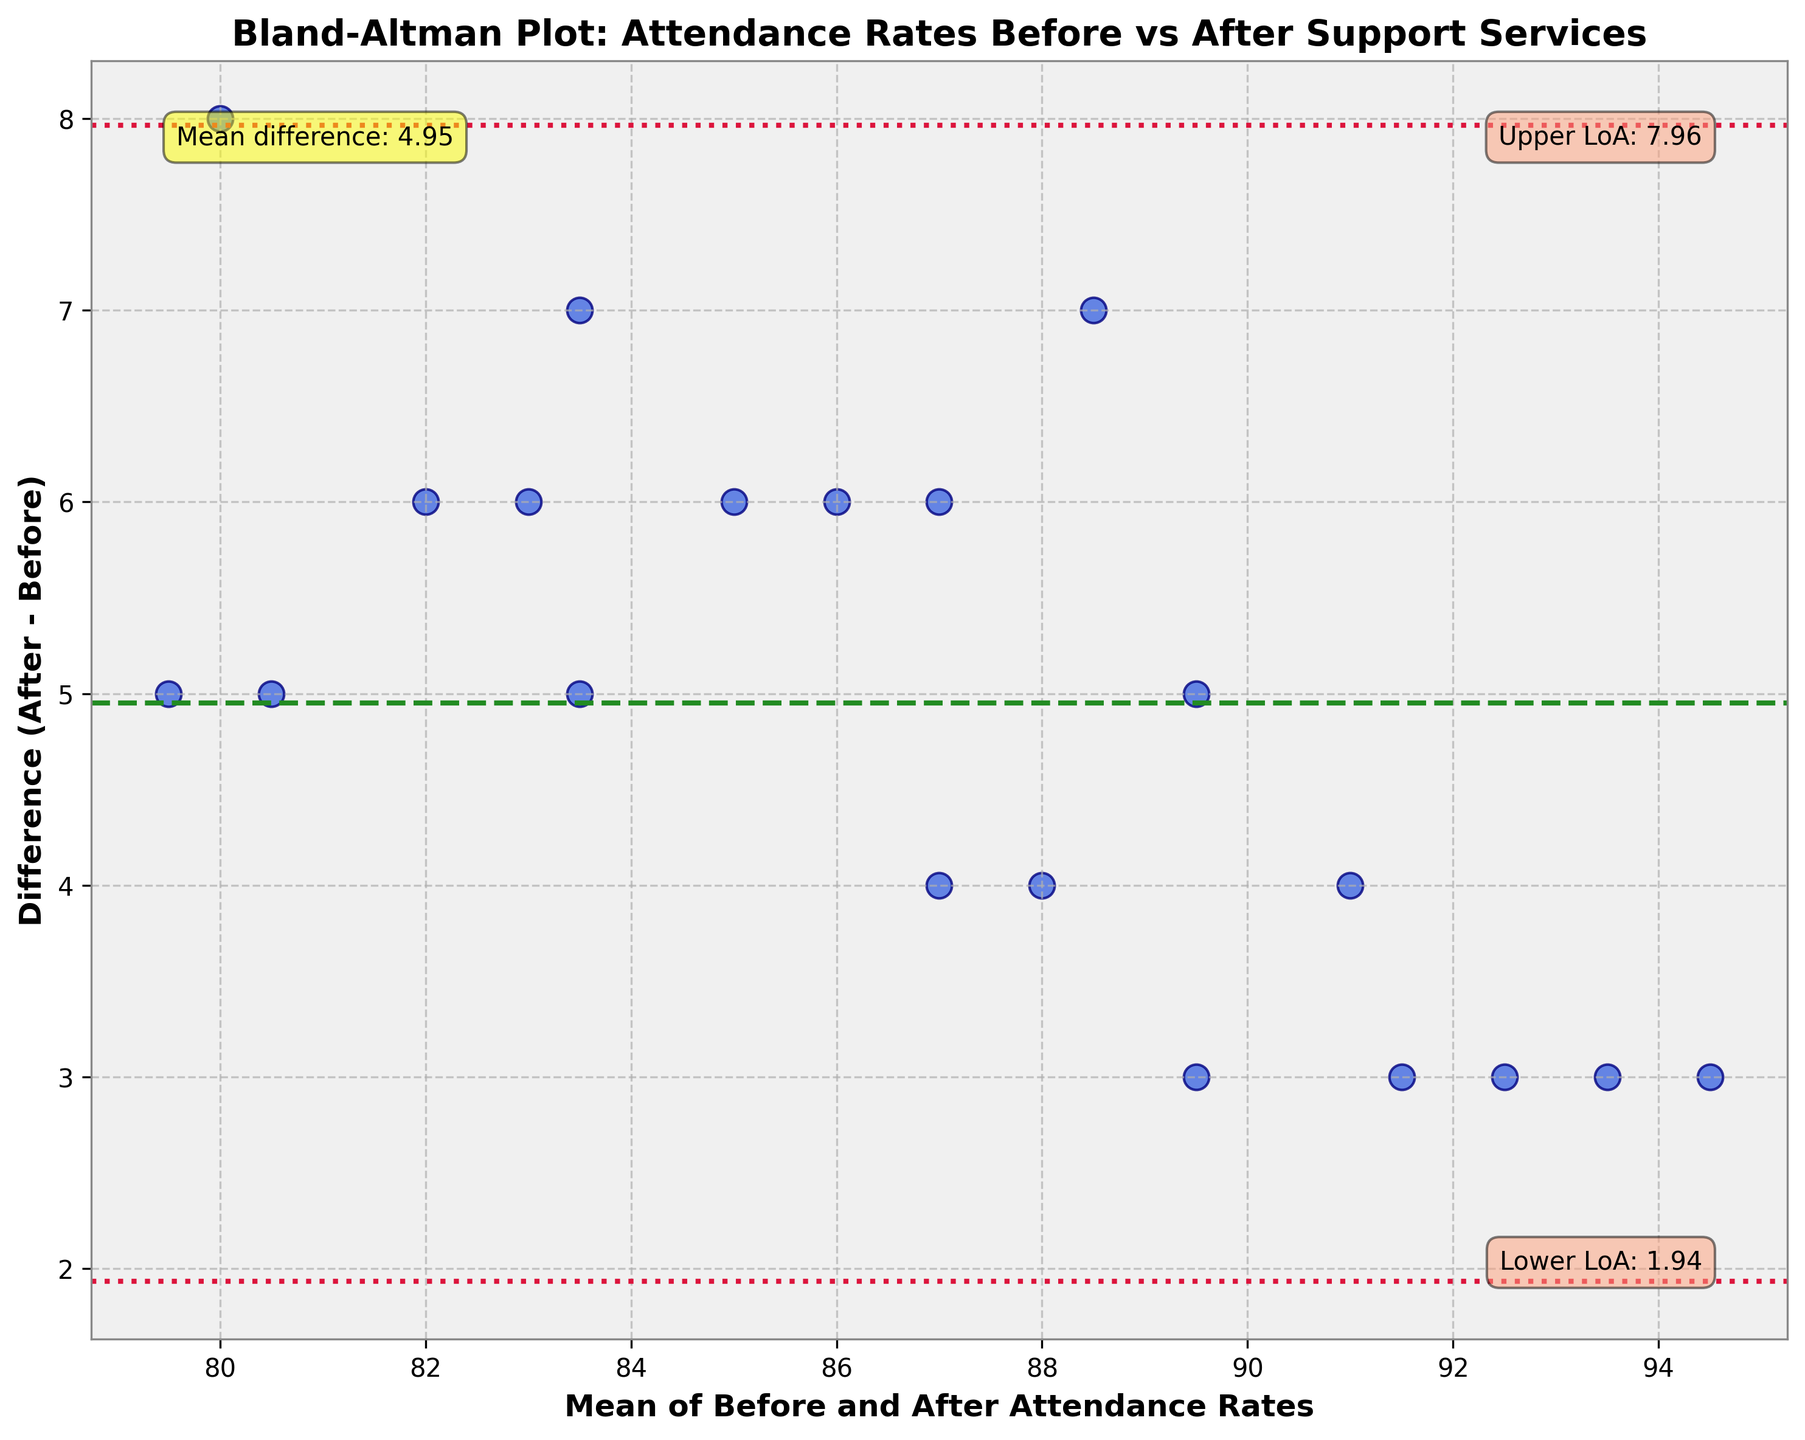What is the title of the plot? The title is located at the top of the plot and provides the main context for the data being visualized. In this case, it mentions that the plot compares attendance rates before and after the implementation of support services.
Answer: Bland-Altman Plot: Attendance Rates Before vs After Support Services How many data points are shown in the plot? The number of data points can be counted by observing the number of scattered points within the plot. Each point represents a student's attendance rate.
Answer: 20 What is the mean difference between attendance rates before and after implementing the new support services? The mean difference is illustrated by the horizontal dashed green line in the plot, and its value is annotated near the top left part within a yellow box.
Answer: 4.65 What are the upper and lower limits of agreement? The limits of agreement are represented by the dotted red lines in the plot and their values are annotated inside the plot with red boxes near the top right and bottom right corners respectively.
Answer: Upper: 7.97, Lower: 1.33 Is there any indication that most students have improved their attendance rates after the new services were implemented? This can be inferred by observing that most data points are above the zero difference line, indicating that the "After" rates are generally higher than the "Before" rates.
Answer: Yes What is the difference in attendance rates for the student with a mean attendance rate of 93? Identify the data point that has its mean value on the x-axis close to 93 and then observe its y-coordinate to find the difference in attendance rates.
Answer: 3 For a mean attendance rate of 80, how much did the attendance rate change? Locate the data point around the x-axis value of 80 and observe the corresponding y-value. This indicates the change in attendance rates.
Answer: 6 Which student showed the highest increase in attendance rate? The highest increase corresponds to the data point with the highest value on the y-axis (difference axis).
Answer: Ethan Taylor (8 points increase) Are any students' attendance rates the same before and after the support services were implemented? Look for any data points on the zero horizontal line (y=0), which would indicate no change.
Answer: No What range of attendance rate improvements did the majority of students experience? By referencing the vertical distribution of most data points around the mean difference line, we can estimate the common range of improvements.
Answer: Between 2 and 7 points 